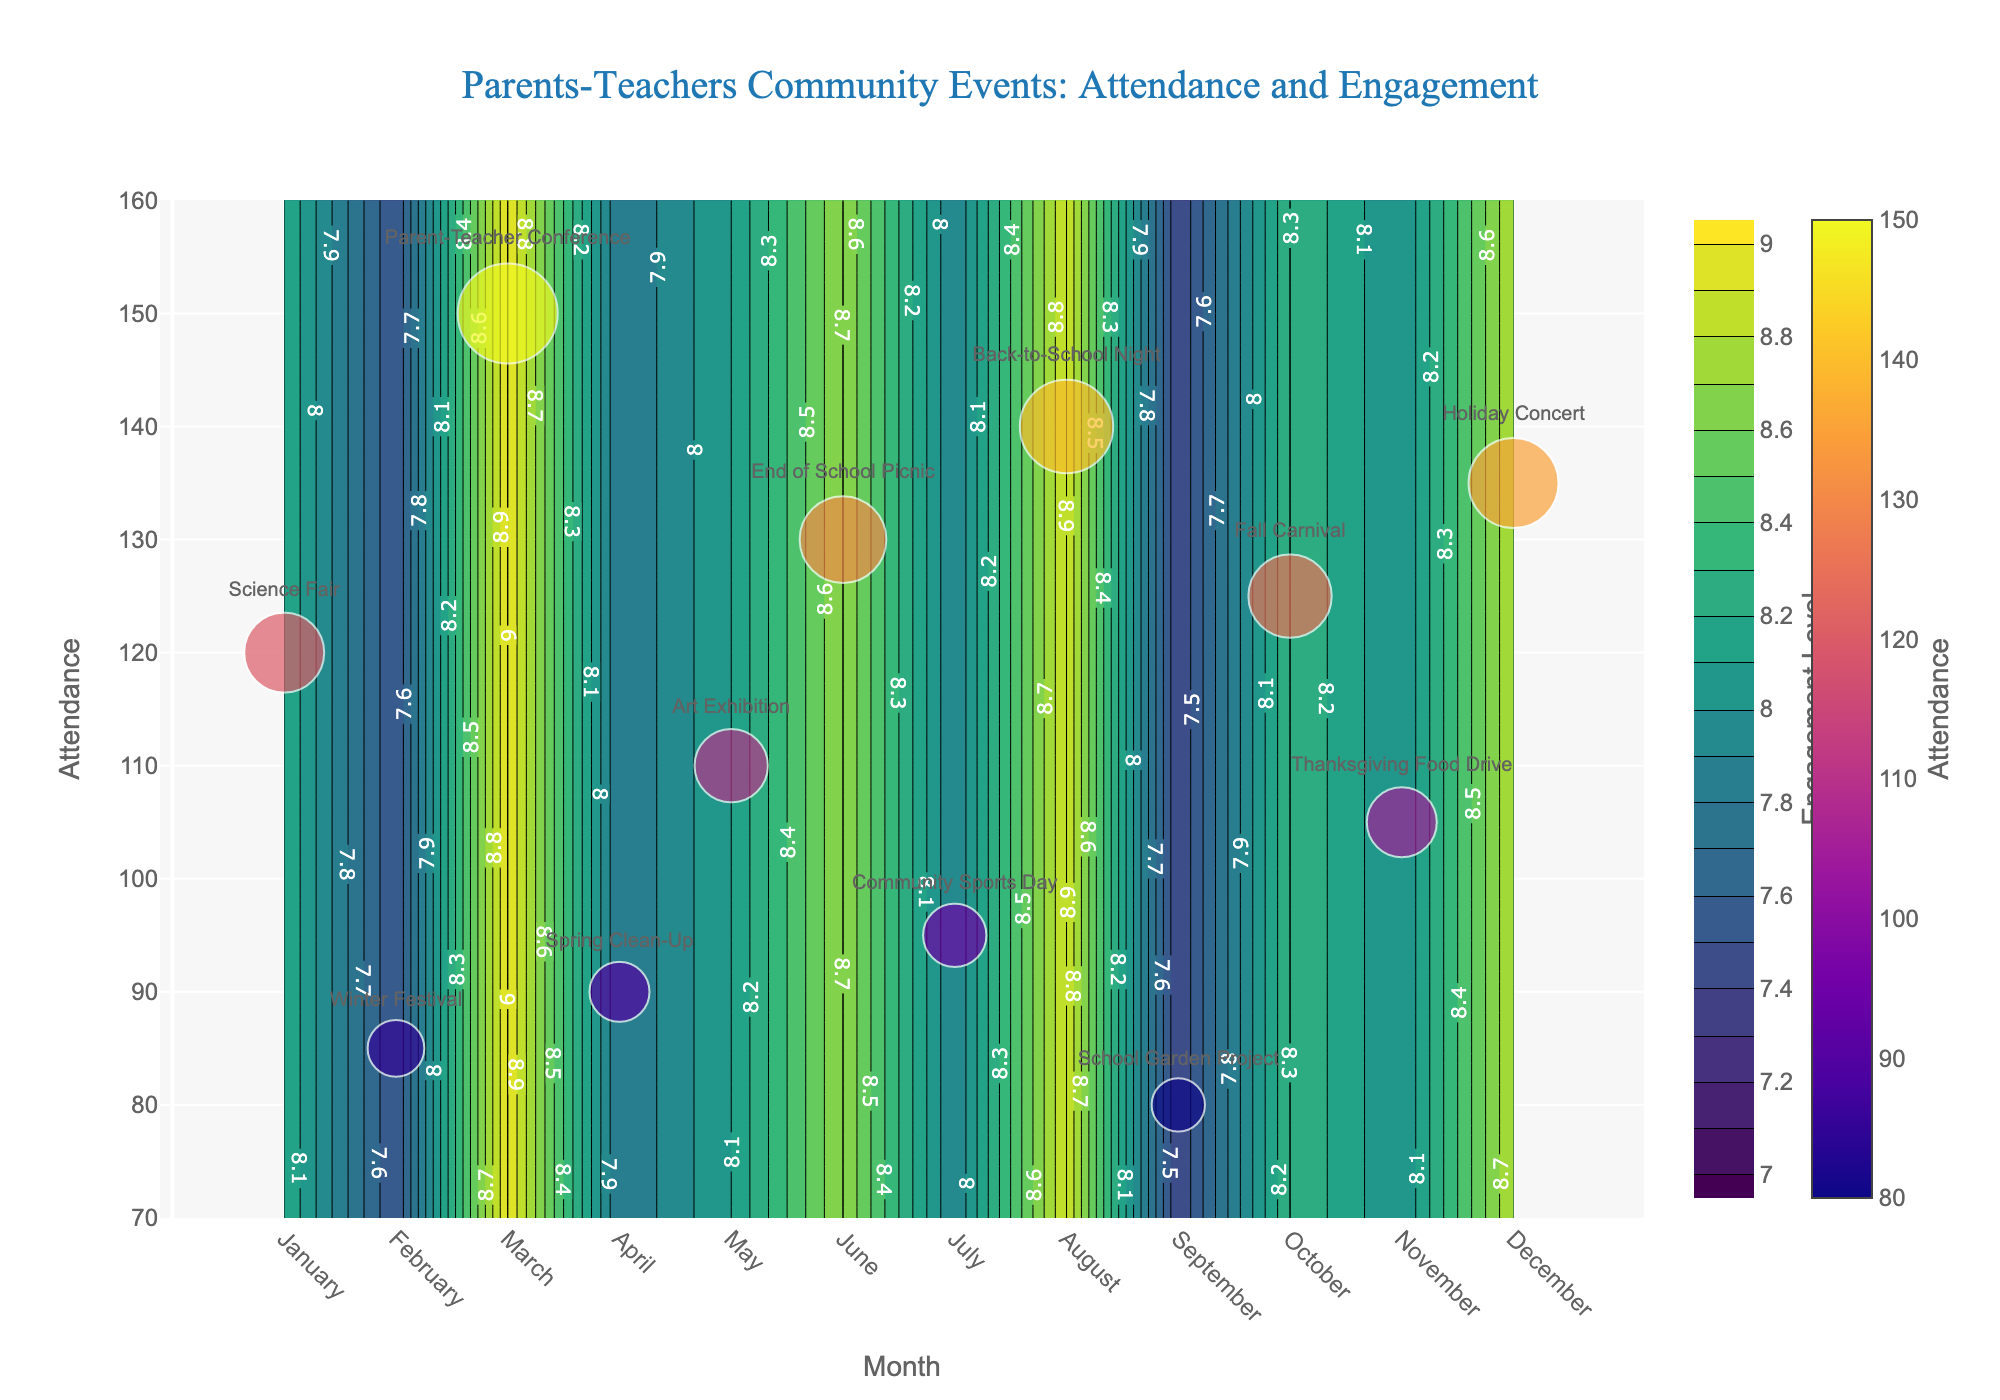Which month had the highest attendance? The month with the highest attendance can be identified by looking at the scatter plot. The biggest circle (which represents the highest attendance) is over the month marked 'March', corresponding to the Parent-Teacher Conference. The attendance for that event is 150.
Answer: March What is the engagement level of the event with the lowest attendance? From the scatter plot, the smallest circle corresponds to 'September' for the School Garden Project with an attendance of 80. This event has an engagement level of 7.4, as indicated by the color in the contour plot.
Answer: 7.4 Which event had an engagement level above 8 but with attendance less than 100? On the contour plot and the scatter plot, events with engagement levels above 8 but attendance less than 100 are shown with the circle size and contour color. The event in 'February' (Winter Festival with 85 attendance) meets these criteria with an engagement level of 7.5, which doesn't satisfy the condition. The correct match is 'April' with Spring Clean-Up having engagement 7.8 and doesn't qualify. Finally, 'July' (Community Sports Day) with an attendance of 95 and engagement of 7.9 qualifies. Therefore, none match engagement level above 8.
Answer: None Which month has the engagement level closest to 9? By looking at the contour plot, engagement levels are color-coded, and the closest to 9 appears in 'March' for the Parent-Teacher Conference. The contour labels help in identifying this value clearly.
Answer: March What is the mean attendance for events with engagement levels higher than 8.5? To find the mean attendance of events with engagement levels higher than 8.5, identify the events: March (150 attendees), June (130), August (140), December (135). Sum these attendances and divide by the count of these events.
Mean Attendance = (150 + 130 + 140 + 135) / 4 = 555 / 4 = 138.75
Answer: 138.75 